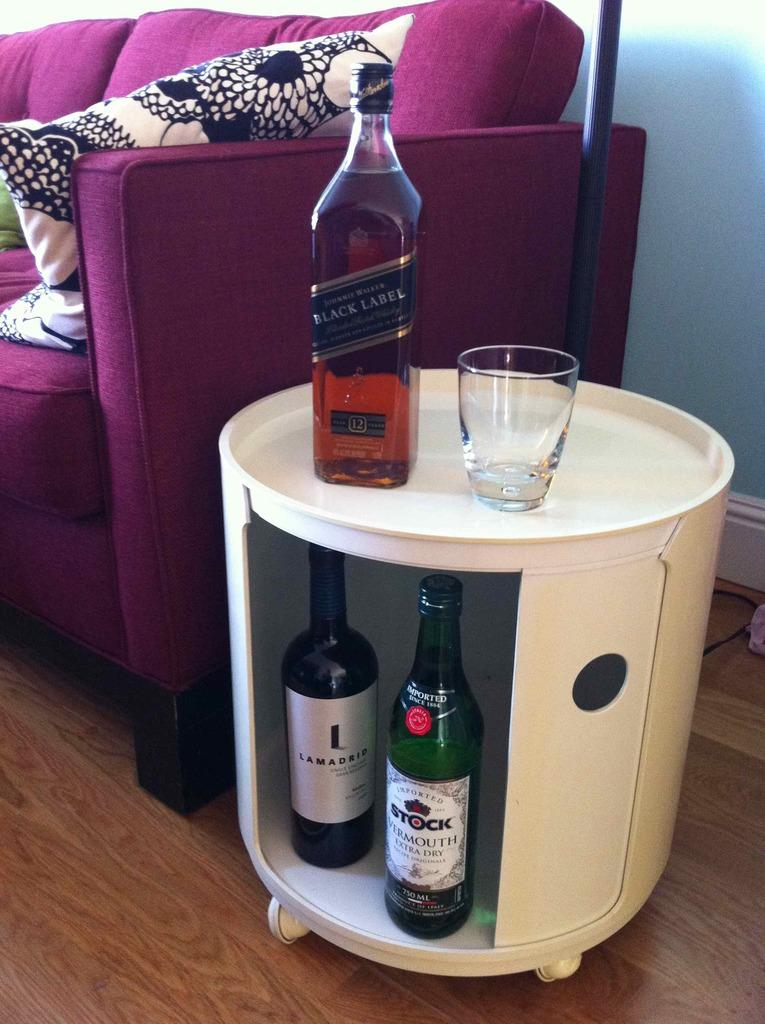What type of beverage containers are in the image? There is a group of wine bottles in the image. What is the purpose of the glass in the image? The glass is likely for drinking the wine. What is unique about the table in the image? The table has 2 wheels. What type of furniture is in the image? There is a couch in the image. What type of accessory is in the image? There is a pillow in the image. What is the background of the image? There is a wall in the image. What type of chess piece is on the couch in the image? There is no chess piece present in the image. What color is the cat sitting on the pillow in the image? There is no cat present in the image. 